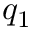<formula> <loc_0><loc_0><loc_500><loc_500>q _ { 1 }</formula> 